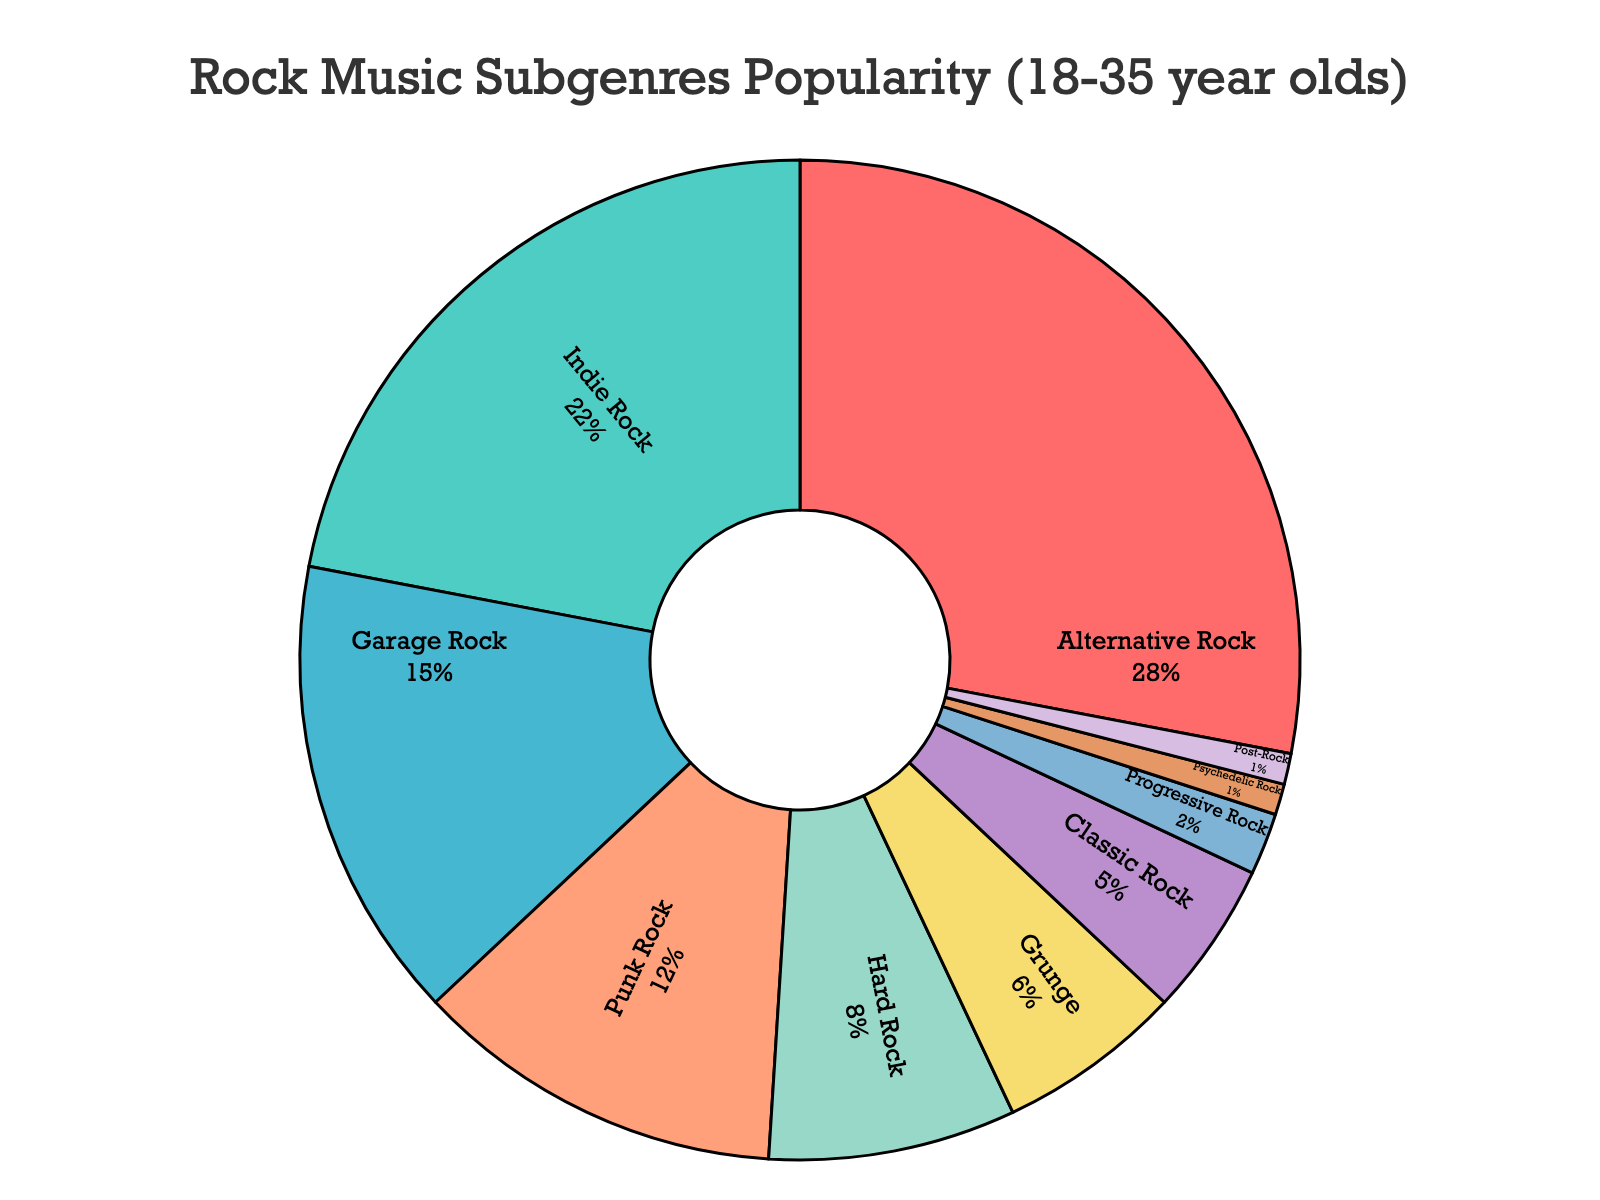Which rock music subgenre is the most popular among 18-35 year olds? The pie chart indicates that the subgenre with the largest percentage is Alternative Rock.
Answer: Alternative Rock Which two subgenres combined make up more than 40% of the total? Combining Alternative Rock with 28% and Indie Rock with 22%, gives 28% + 22% = 50%, which is more than 40%.
Answer: Alternative Rock and Indie Rock How many subgenres have a popularity percentage of 5% or lower? The pie chart shows Classic Rock (5%), Progressive Rock (2%), Psychedelic Rock (1%), and Post-Rock (1%). There are 4 subgenres.
Answer: 4 What is the difference in popularity between Garage Rock and Punk Rock? Garage Rock has 15% while Punk Rock has 12%. The difference is 15% - 12% = 3%.
Answer: 3% Which subgenre occupies a similar portion as Classic Rock? The chart shows that Progressive Rock (2%), Psychedelic Rock (1%), and Post-Rock (1%) are each smaller than Classic Rock (5%). None of the subgenres have a similar portion as Classic Rock.
Answer: None What is the combined percentage of the bottom three subgenres? The bottom three subgenres are Psychedelic Rock (1%), Post-Rock (1%), and Progressive Rock (2%). Their combined percentage is 1% + 1% + 2% = 4%.
Answer: 4% Which subgenre is represented by the blue slice in the pie chart? Visually identifying the blue slice in the legend and chart indicates it corresponds to Indie Rock.
Answer: Indie Rock What is the difference in percentage between the most popular and the least popular subgenres? The most popular is Alternative Rock with 28% and the least popular are Psychedelic Rock and Post-Rock both with 1%. The difference is 28% - 1% = 27%.
Answer: 27% How many subgenres have a higher popularity than Hard Rock? Hard Rock has 8%, and the subgenres with higher percentages are Alternative Rock (28%), Indie Rock (22%), Garage Rock (15%), and Punk Rock (12%). There are 4 subgenres.
Answer: 4 What is the total percentage represented by Alternative Rock, Indie Rock, and Garage Rock? Their respective percentages are 28%, 22%, and 15%. Combined, it's 28% + 22% + 15% = 65%.
Answer: 65% 